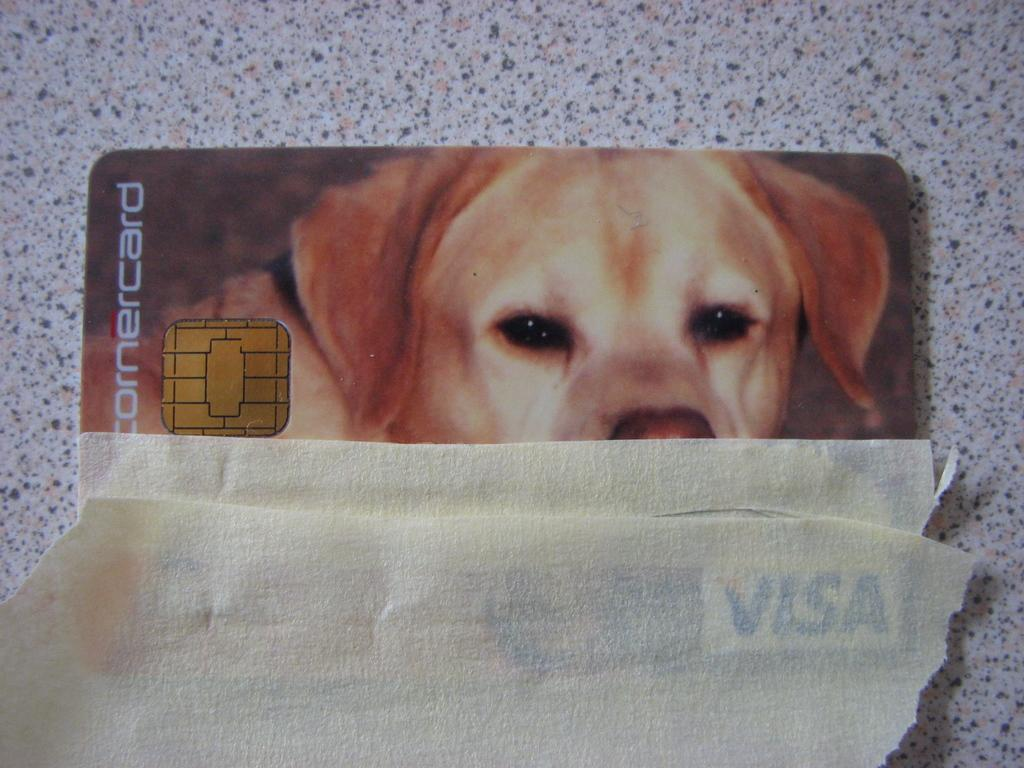What type of car is in the image? There is an electronic car in the image. What is the surface beneath the electronic car? The electronic car is on a marble floor. What can be seen on a card in the image? There is a photo of a dog on a card in the image. How many pieces of paper are on the floor in the image? There are two pieces of paper on the floor in the image. What is the answer to the story told by the cast in the image? There is no story or cast present in the image; it features an electronic car on a marble floor, a card with a photo of a dog, and two pieces of paper on the floor. 